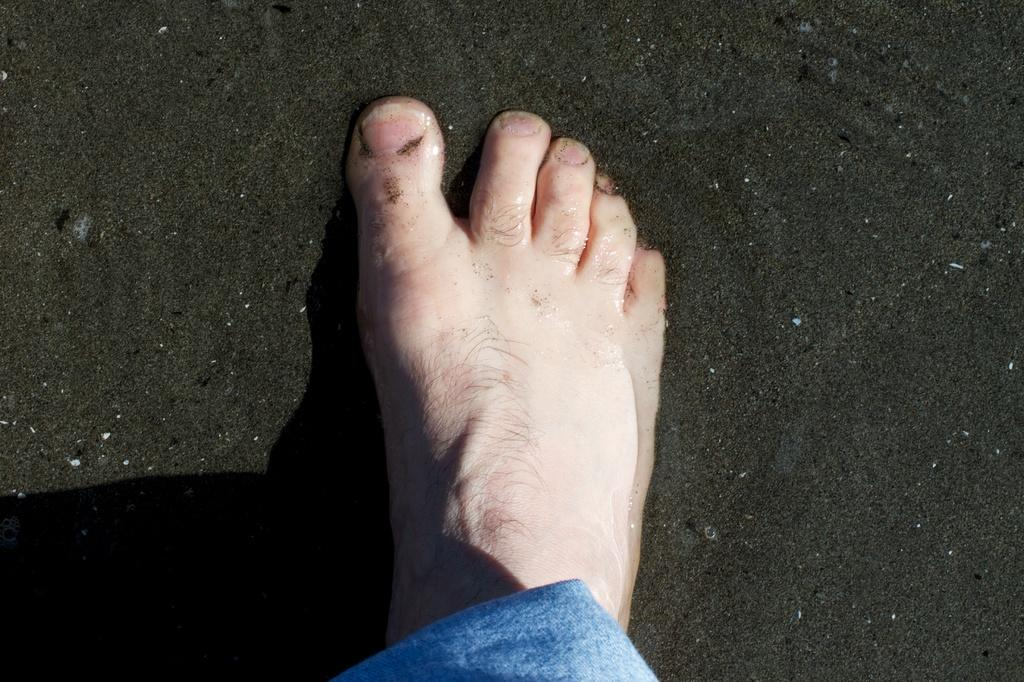What is visible on the sand in the image? There is a person's foot on the sand. What else can be seen in the image besides the foot on the sand? There is water visible in the image. Where is the throne located in the image? There is no throne present in the image. What is the value of the quarter in the image? There is no quarter present in the image. 